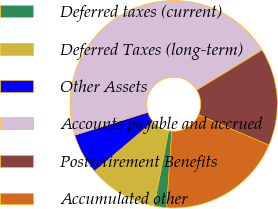<chart> <loc_0><loc_0><loc_500><loc_500><pie_chart><fcel>Deferred taxes (current)<fcel>Deferred Taxes (long-term)<fcel>Other Assets<fcel>Accounts payable and accrued<fcel>Postretirement Benefits<fcel>Accumulated other<nl><fcel>1.95%<fcel>10.78%<fcel>6.37%<fcel>46.09%<fcel>15.2%<fcel>19.61%<nl></chart> 